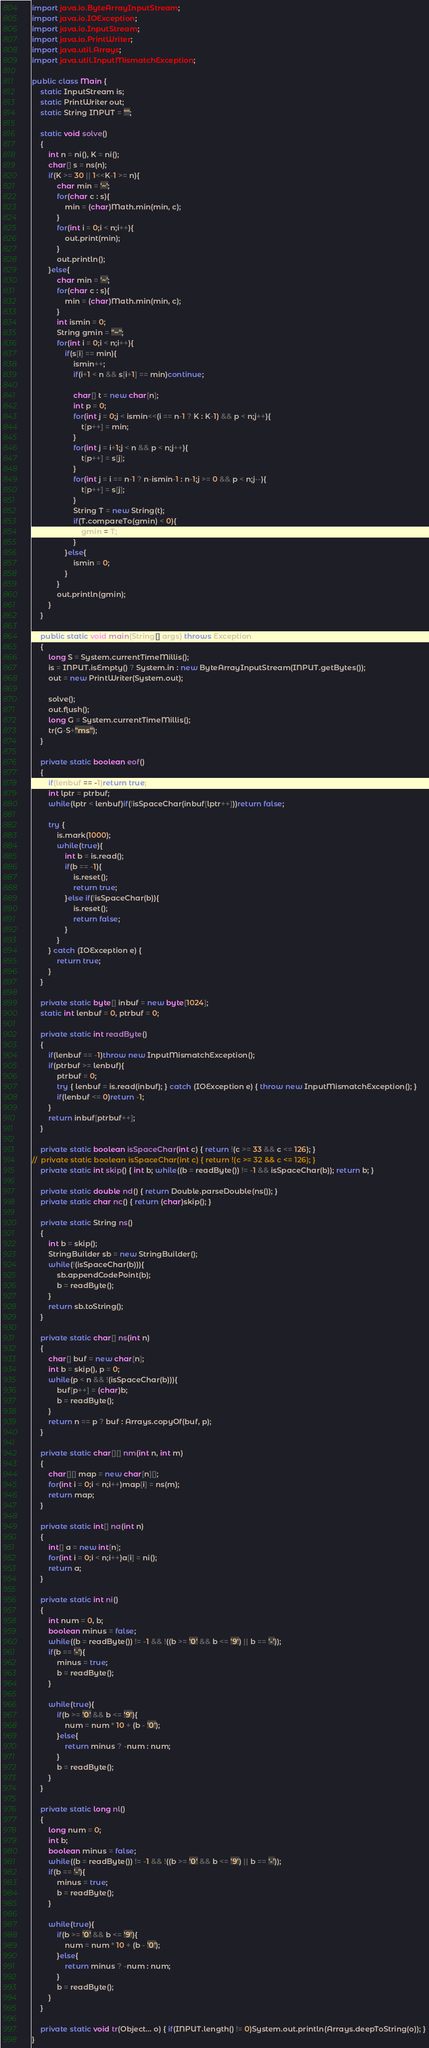<code> <loc_0><loc_0><loc_500><loc_500><_Java_>import java.io.ByteArrayInputStream;
import java.io.IOException;
import java.io.InputStream;
import java.io.PrintWriter;
import java.util.Arrays;
import java.util.InputMismatchException;

public class Main {
	static InputStream is;
	static PrintWriter out;
	static String INPUT = "";
	
	static void solve()
	{
		int n = ni(), K = ni();
		char[] s = ns(n);
		if(K >= 30 || 1<<K-1 >= n){
			char min = '~';
			for(char c : s){
				min = (char)Math.min(min, c);
			}
			for(int i = 0;i < n;i++){
				out.print(min);
			}
			out.println();
		}else{
			char min = '~';
			for(char c : s){
				min = (char)Math.min(min, c);
			}
			int ismin = 0;
			String gmin = "~";
			for(int i = 0;i < n;i++){
				if(s[i] == min){
					ismin++;
					if(i+1 < n && s[i+1] == min)continue;
					
					char[] t = new char[n];
					int p = 0;
					for(int j = 0;j < ismin<<(i == n-1 ? K : K-1) && p < n;j++){
						t[p++] = min;
					}
					for(int j = i+1;j < n && p < n;j++){
						t[p++] = s[j];
					}
					for(int j = i == n-1 ? n-ismin-1 : n-1;j >= 0 && p < n;j--){
						t[p++] = s[j];
					}
					String T = new String(t);
					if(T.compareTo(gmin) < 0){
						gmin = T;
					}
				}else{
					ismin = 0;
				}
			}
			out.println(gmin);
		}
	}
	
	public static void main(String[] args) throws Exception
	{
		long S = System.currentTimeMillis();
		is = INPUT.isEmpty() ? System.in : new ByteArrayInputStream(INPUT.getBytes());
		out = new PrintWriter(System.out);
		
		solve();
		out.flush();
		long G = System.currentTimeMillis();
		tr(G-S+"ms");
	}
	
	private static boolean eof()
	{
		if(lenbuf == -1)return true;
		int lptr = ptrbuf;
		while(lptr < lenbuf)if(!isSpaceChar(inbuf[lptr++]))return false;
		
		try {
			is.mark(1000);
			while(true){
				int b = is.read();
				if(b == -1){
					is.reset();
					return true;
				}else if(!isSpaceChar(b)){
					is.reset();
					return false;
				}
			}
		} catch (IOException e) {
			return true;
		}
	}
	
	private static byte[] inbuf = new byte[1024];
	static int lenbuf = 0, ptrbuf = 0;
	
	private static int readByte()
	{
		if(lenbuf == -1)throw new InputMismatchException();
		if(ptrbuf >= lenbuf){
			ptrbuf = 0;
			try { lenbuf = is.read(inbuf); } catch (IOException e) { throw new InputMismatchException(); }
			if(lenbuf <= 0)return -1;
		}
		return inbuf[ptrbuf++];
	}
	
	private static boolean isSpaceChar(int c) { return !(c >= 33 && c <= 126); }
//	private static boolean isSpaceChar(int c) { return !(c >= 32 && c <= 126); }
	private static int skip() { int b; while((b = readByte()) != -1 && isSpaceChar(b)); return b; }
	
	private static double nd() { return Double.parseDouble(ns()); }
	private static char nc() { return (char)skip(); }
	
	private static String ns()
	{
		int b = skip();
		StringBuilder sb = new StringBuilder();
		while(!(isSpaceChar(b))){
			sb.appendCodePoint(b);
			b = readByte();
		}
		return sb.toString();
	}
	
	private static char[] ns(int n)
	{
		char[] buf = new char[n];
		int b = skip(), p = 0;
		while(p < n && !(isSpaceChar(b))){
			buf[p++] = (char)b;
			b = readByte();
		}
		return n == p ? buf : Arrays.copyOf(buf, p);
	}
	
	private static char[][] nm(int n, int m)
	{
		char[][] map = new char[n][];
		for(int i = 0;i < n;i++)map[i] = ns(m);
		return map;
	}
	
	private static int[] na(int n)
	{
		int[] a = new int[n];
		for(int i = 0;i < n;i++)a[i] = ni();
		return a;
	}
	
	private static int ni()
	{
		int num = 0, b;
		boolean minus = false;
		while((b = readByte()) != -1 && !((b >= '0' && b <= '9') || b == '-'));
		if(b == '-'){
			minus = true;
			b = readByte();
		}
		
		while(true){
			if(b >= '0' && b <= '9'){
				num = num * 10 + (b - '0');
			}else{
				return minus ? -num : num;
			}
			b = readByte();
		}
	}
	
	private static long nl()
	{
		long num = 0;
		int b;
		boolean minus = false;
		while((b = readByte()) != -1 && !((b >= '0' && b <= '9') || b == '-'));
		if(b == '-'){
			minus = true;
			b = readByte();
		}
		
		while(true){
			if(b >= '0' && b <= '9'){
				num = num * 10 + (b - '0');
			}else{
				return minus ? -num : num;
			}
			b = readByte();
		}
	}
	
	private static void tr(Object... o) { if(INPUT.length() != 0)System.out.println(Arrays.deepToString(o)); }
}
</code> 